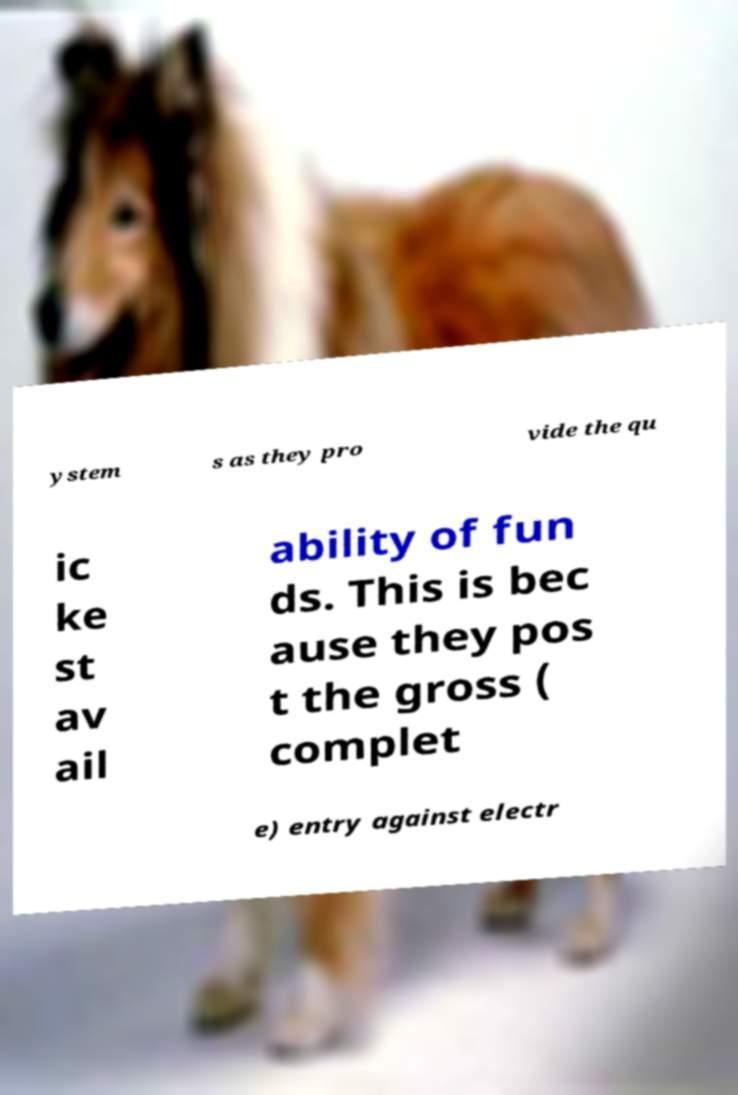Could you assist in decoding the text presented in this image and type it out clearly? ystem s as they pro vide the qu ic ke st av ail ability of fun ds. This is bec ause they pos t the gross ( complet e) entry against electr 